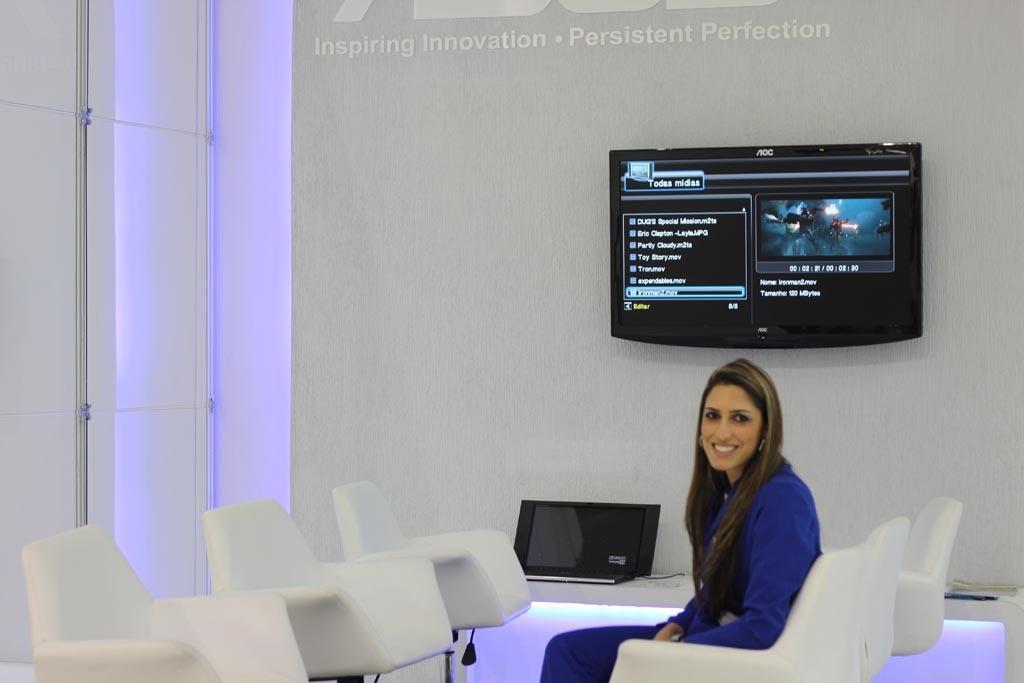In one or two sentences, can you explain what this image depicts? In the image we can see there is a person who is sitting on chair and on wall there is tv. 